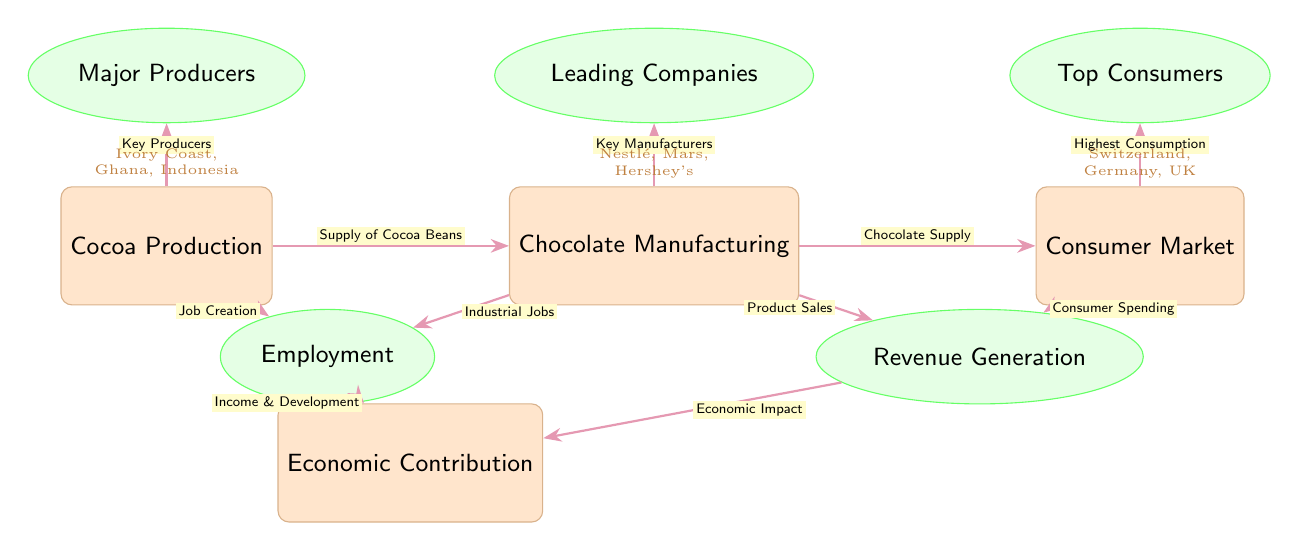What is the main type of production depicted in the diagram? The main type of production in the diagram is indicated by the first node, which is labeled "Cocoa Production." This node is a foundational aspect of the chocolate industry, showing that cocoa is the primary ingredient for chocolate.
Answer: Cocoa Production Who are the major consumers of chocolate according to the diagram? The node labeled "Top Consumers" identifies specific countries known for high chocolate consumption. This node points to Switzerland, Germany, and the UK, which highlights regions where chocolate demand is significant.
Answer: Switzerland, Germany, UK What connects cocoa production to employment according to the diagram? The line labeled "Job Creation" directly connects the "Cocoa Production" node to the "Employment" sub-node below it. This indicates that cocoa production generates jobs, adding to economic growth in related sectors.
Answer: Job Creation Which companies are identified as leading in chocolate manufacturing? The node specified as "Leading Companies" points to major industry players, including Nestlé, Mars, and Hershey's, demonstrating important manufacturing entities within the chocolate supply chain.
Answer: Nestlé, Mars, Hershey's How does the consumer market contribute to economic impact? The diagram illustrates that "Consumer Spending" from the consumer market node connects to the "Revenue Generation" node. This implies that the financial transactions and expenditures by consumers with chocolate products directly contribute to the overall economic impact.
Answer: Economic Impact What type of job creation is connected to chocolate manufacturing? The line labeled "Industrial Jobs" connects "Chocolate Manufacturing" to the "Employment" sub-node. This shows that manufacturing chocolate creates specific types of industrial employment opportunities in the sector.
Answer: Industrial Jobs How does chocolate manufacturing link to revenue generation? The relationship between the "Chocolate Manufacturing" node and the "Revenue Generation" sub-node illustrates that through the process of producing chocolate, companies generate revenue from product sales, which is a critical economic factor.
Answer: Product Sales What is the overall economic contribution of cocoa production and chocolate manufacturing? The final connection from both "Employment" and "Revenue Generation" nodes to the "Economic Contribution" node signifies that both job creation and revenue stem from these industries, thereby highlighting their combined importance to the economy.
Answer: Economic Contribution 